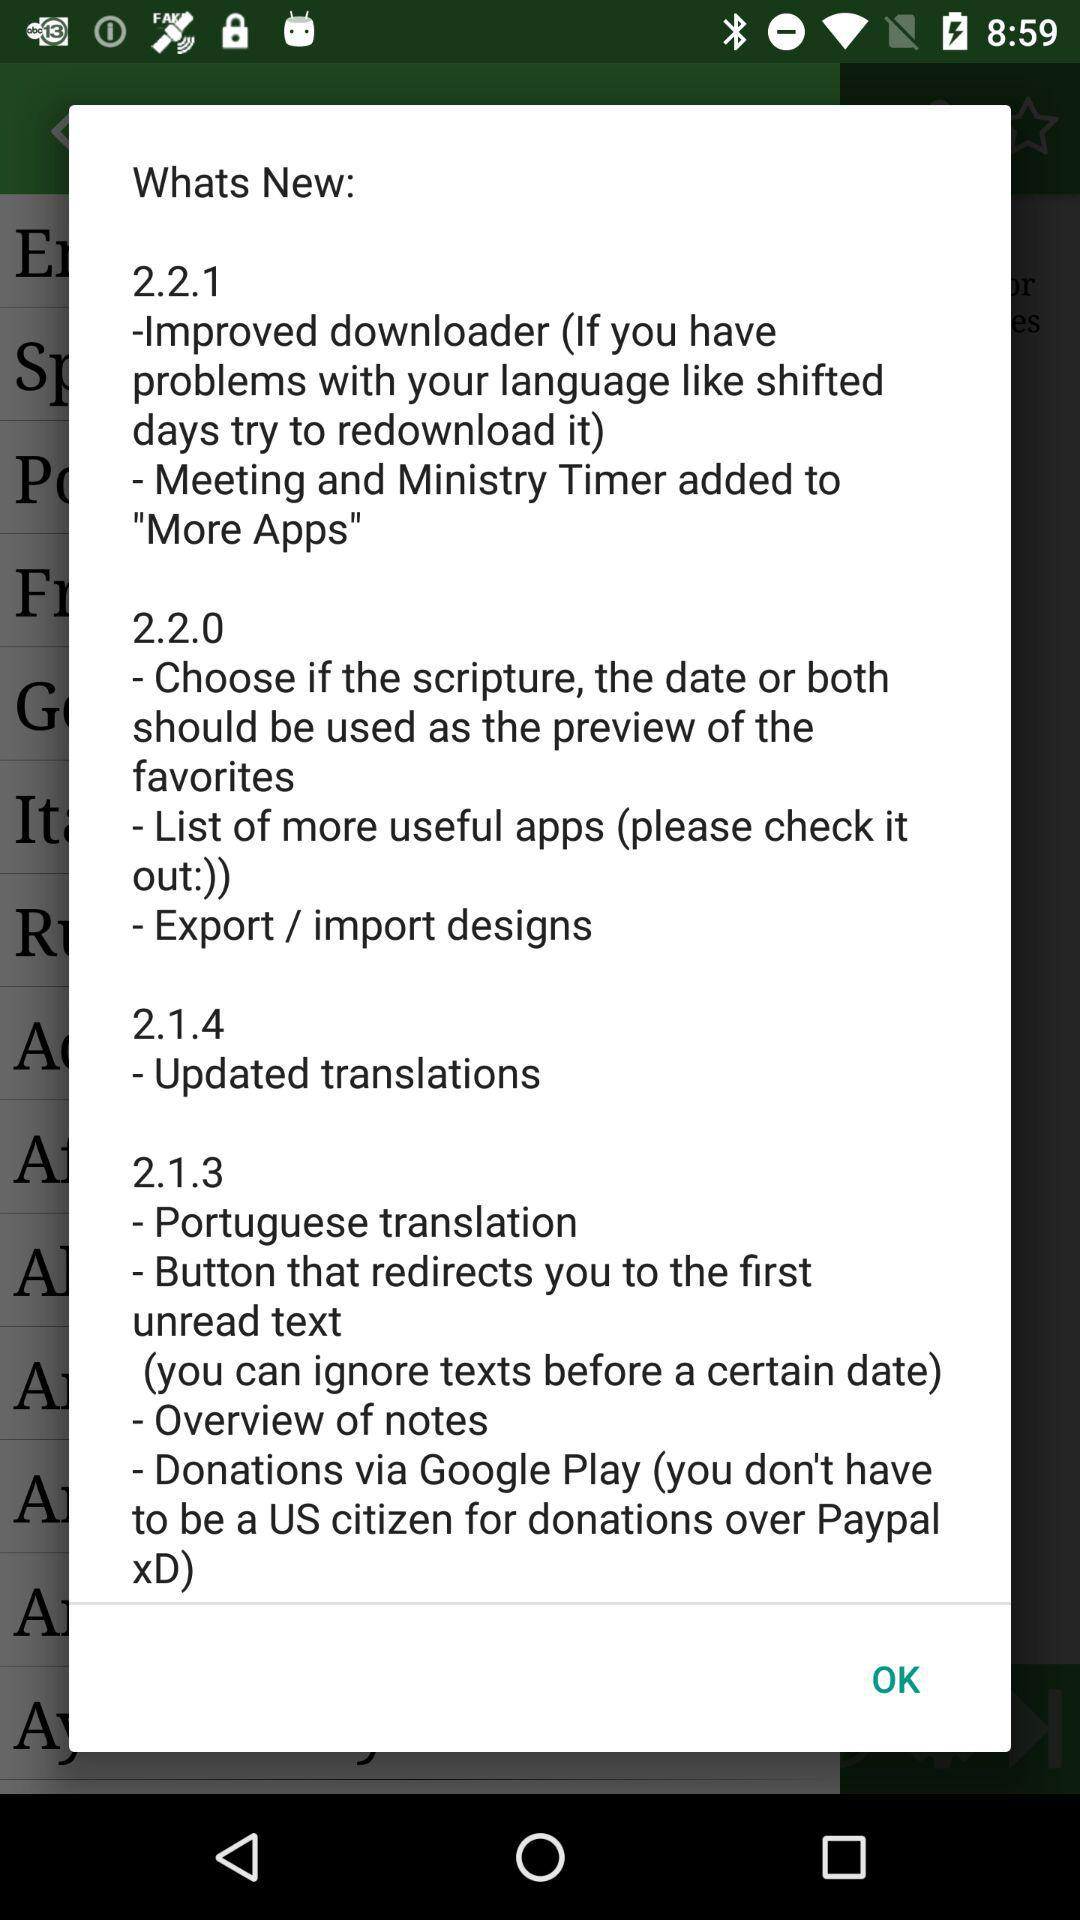What new changes were made in version 2.2.1? The new changes are "Improved downloader (If you have problems with your language like shifted days try to redownload it)" and "Meeting and Ministry Timer added to "More Apps"". 